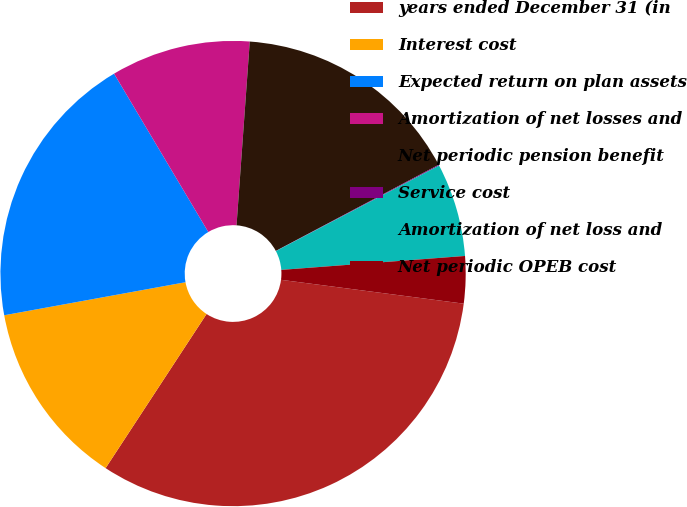Convert chart. <chart><loc_0><loc_0><loc_500><loc_500><pie_chart><fcel>years ended December 31 (in<fcel>Interest cost<fcel>Expected return on plan assets<fcel>Amortization of net losses and<fcel>Net periodic pension benefit<fcel>Service cost<fcel>Amortization of net loss and<fcel>Net periodic OPEB cost<nl><fcel>32.16%<fcel>12.9%<fcel>19.32%<fcel>9.69%<fcel>16.11%<fcel>0.06%<fcel>6.48%<fcel>3.27%<nl></chart> 